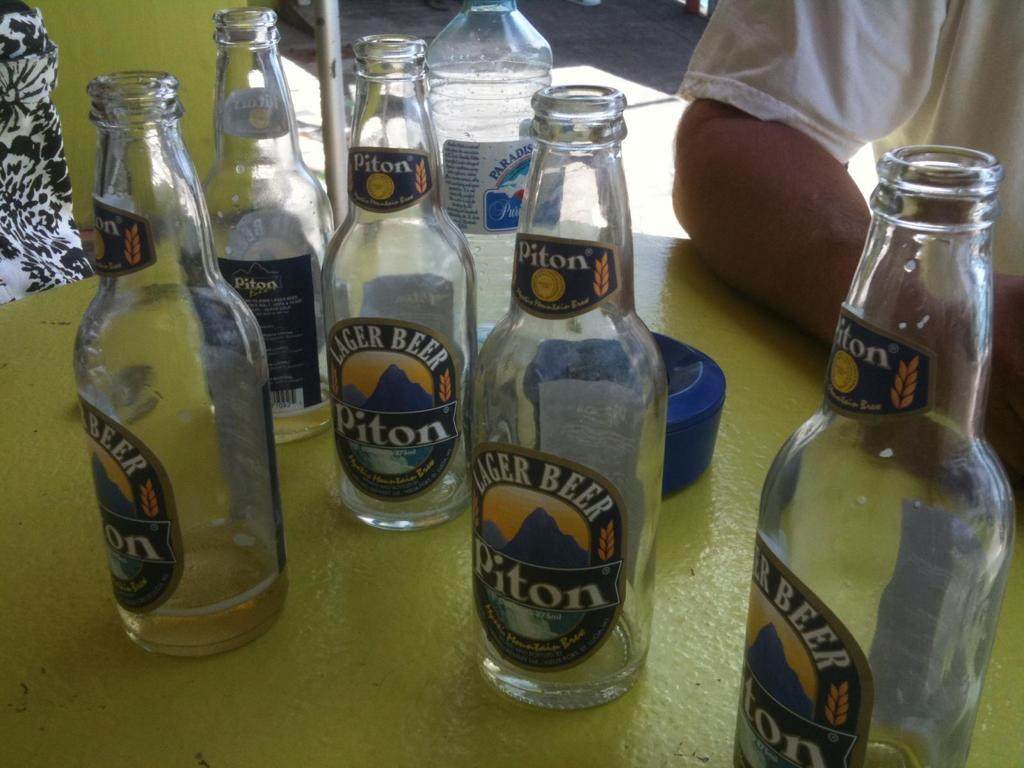<image>
Share a concise interpretation of the image provided. Empty bottles of Piton sit on a chartreuse table. 